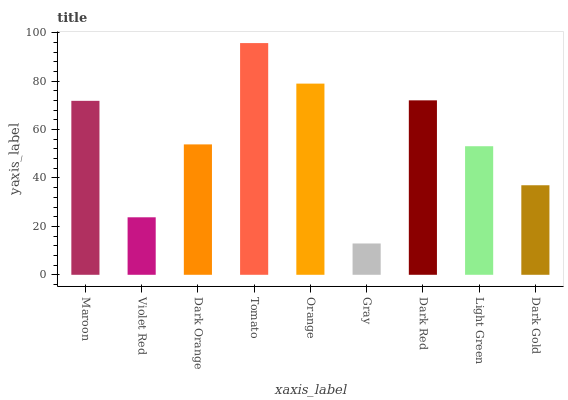Is Gray the minimum?
Answer yes or no. Yes. Is Tomato the maximum?
Answer yes or no. Yes. Is Violet Red the minimum?
Answer yes or no. No. Is Violet Red the maximum?
Answer yes or no. No. Is Maroon greater than Violet Red?
Answer yes or no. Yes. Is Violet Red less than Maroon?
Answer yes or no. Yes. Is Violet Red greater than Maroon?
Answer yes or no. No. Is Maroon less than Violet Red?
Answer yes or no. No. Is Dark Orange the high median?
Answer yes or no. Yes. Is Dark Orange the low median?
Answer yes or no. Yes. Is Tomato the high median?
Answer yes or no. No. Is Orange the low median?
Answer yes or no. No. 